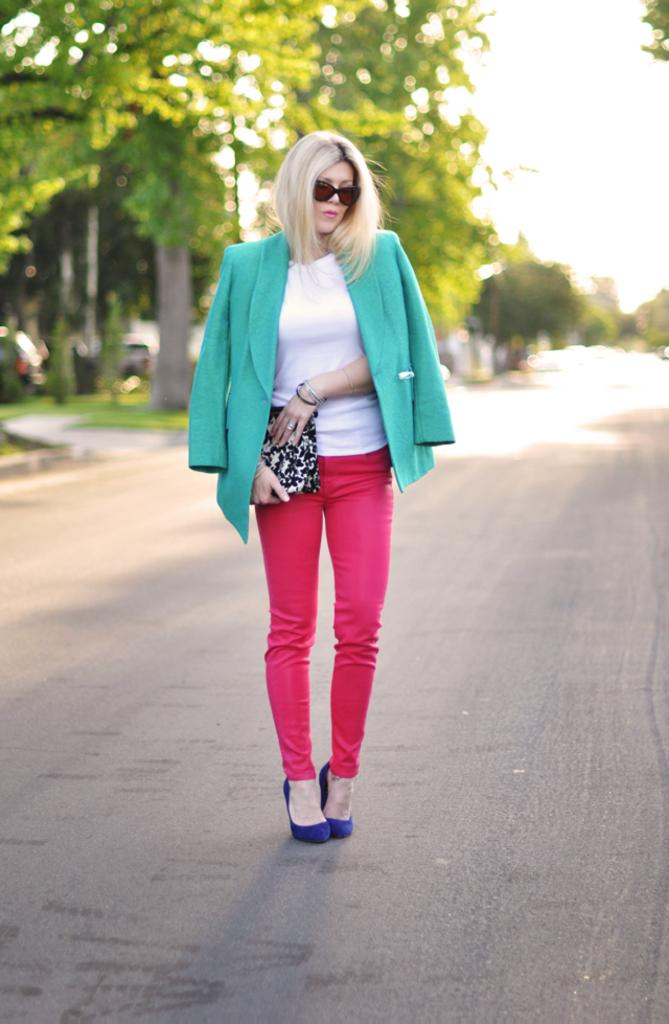Who is the main subject in the image? There is a lady in the image. What is the lady wearing on her face? The lady is wearing goggles. What is the lady holding in her hand? The lady is holding a bag. Where is the lady standing in the image? The lady is standing on a road. What can be seen in the background of the image? There are trees and the sky visible in the background of the image. What type of cover is the lady using to protect herself from the marble in the image? There is no mention of a marble or any need for a cover in the image. 